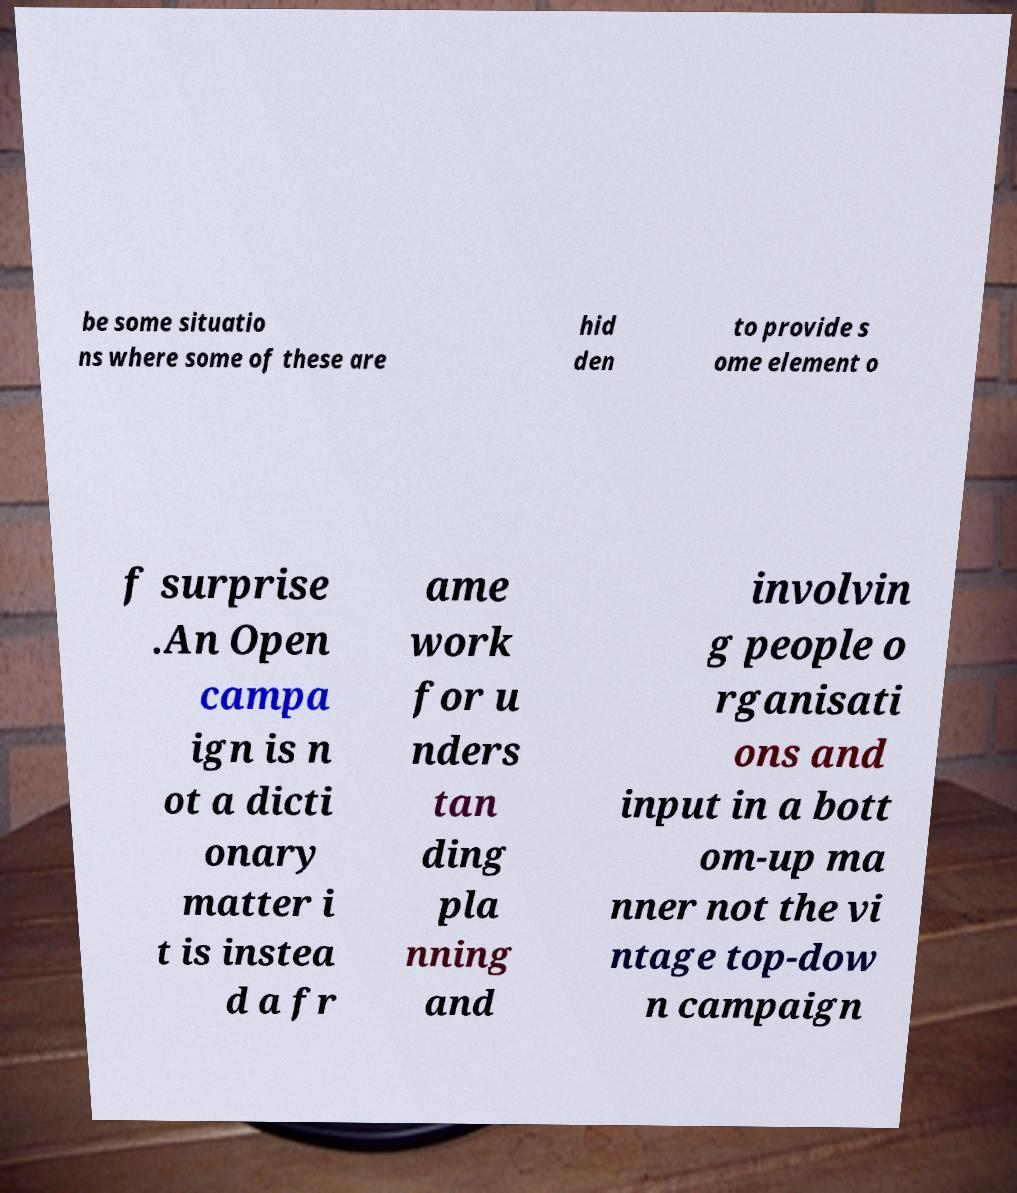Can you accurately transcribe the text from the provided image for me? be some situatio ns where some of these are hid den to provide s ome element o f surprise .An Open campa ign is n ot a dicti onary matter i t is instea d a fr ame work for u nders tan ding pla nning and involvin g people o rganisati ons and input in a bott om-up ma nner not the vi ntage top-dow n campaign 